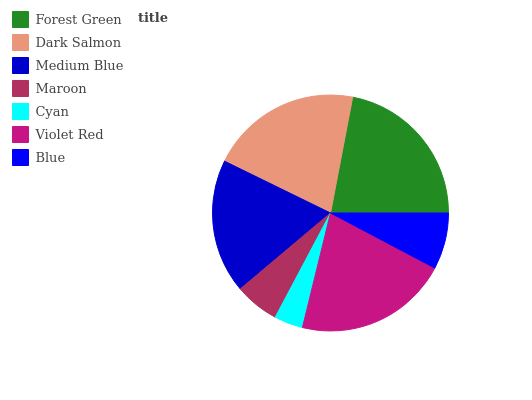Is Cyan the minimum?
Answer yes or no. Yes. Is Forest Green the maximum?
Answer yes or no. Yes. Is Dark Salmon the minimum?
Answer yes or no. No. Is Dark Salmon the maximum?
Answer yes or no. No. Is Forest Green greater than Dark Salmon?
Answer yes or no. Yes. Is Dark Salmon less than Forest Green?
Answer yes or no. Yes. Is Dark Salmon greater than Forest Green?
Answer yes or no. No. Is Forest Green less than Dark Salmon?
Answer yes or no. No. Is Medium Blue the high median?
Answer yes or no. Yes. Is Medium Blue the low median?
Answer yes or no. Yes. Is Forest Green the high median?
Answer yes or no. No. Is Forest Green the low median?
Answer yes or no. No. 